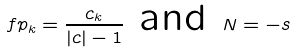Convert formula to latex. <formula><loc_0><loc_0><loc_500><loc_500>\ f p _ { k } = \frac { c _ { k } } { | c | - 1 } \text { and } N = - s</formula> 